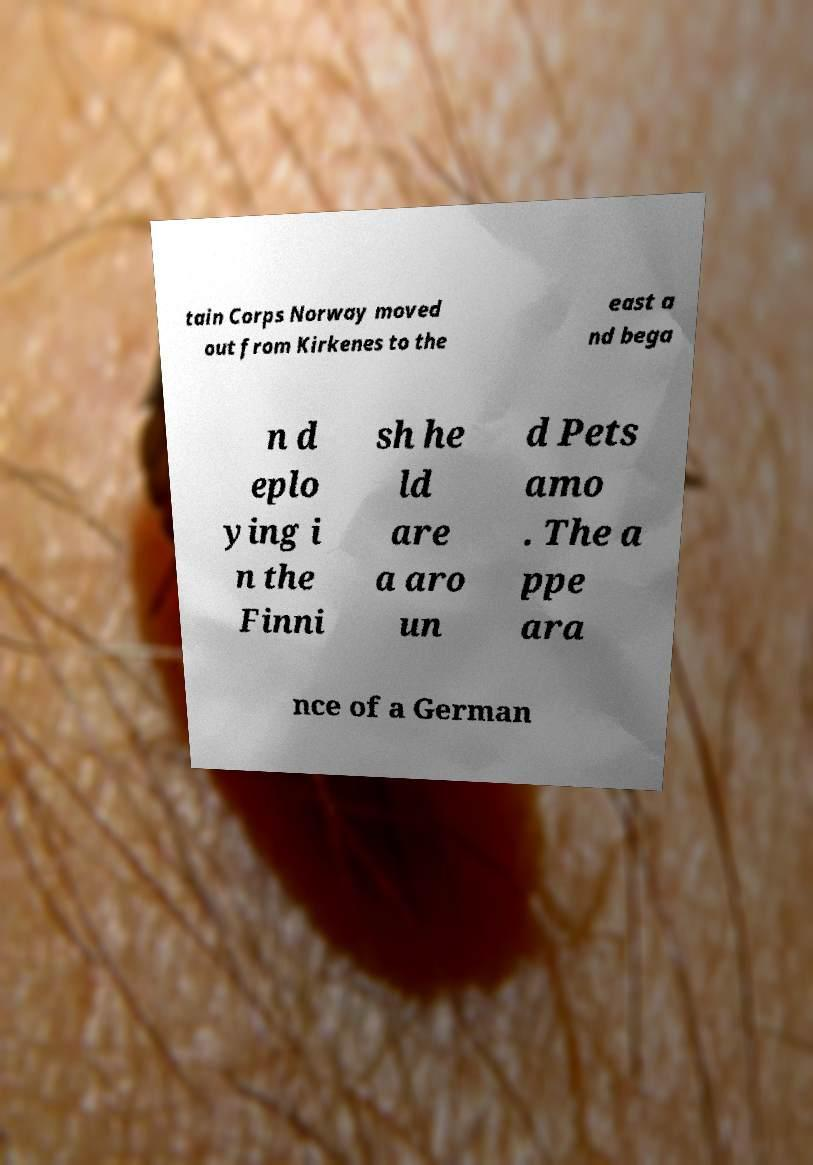What messages or text are displayed in this image? I need them in a readable, typed format. tain Corps Norway moved out from Kirkenes to the east a nd bega n d eplo ying i n the Finni sh he ld are a aro un d Pets amo . The a ppe ara nce of a German 